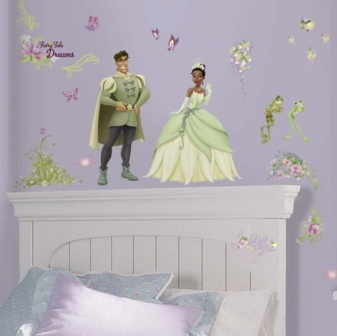If you were to add another element to this bedroom scene, what would it be? Adding a scenic castle sticker in the background or a magical rainbow arching above the prince and princess could enhance the fairytale theme of this bedroom scene. It would add a sense of depth and adventure, making the room even more enchanting. 